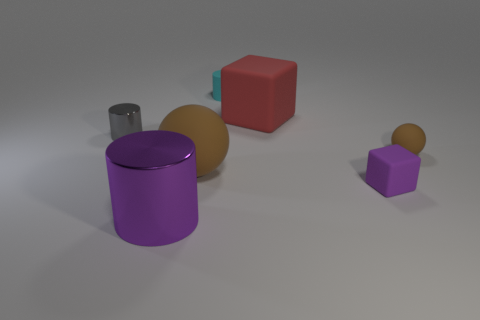Add 2 green matte objects. How many objects exist? 9 Subtract all small cylinders. How many cylinders are left? 1 Subtract all purple blocks. How many blocks are left? 1 Subtract all cylinders. How many objects are left? 4 Add 2 red rubber cubes. How many red rubber cubes are left? 3 Add 7 large purple objects. How many large purple objects exist? 8 Subtract 0 red cylinders. How many objects are left? 7 Subtract 3 cylinders. How many cylinders are left? 0 Subtract all gray spheres. Subtract all red blocks. How many spheres are left? 2 Subtract all blue blocks. How many purple cylinders are left? 1 